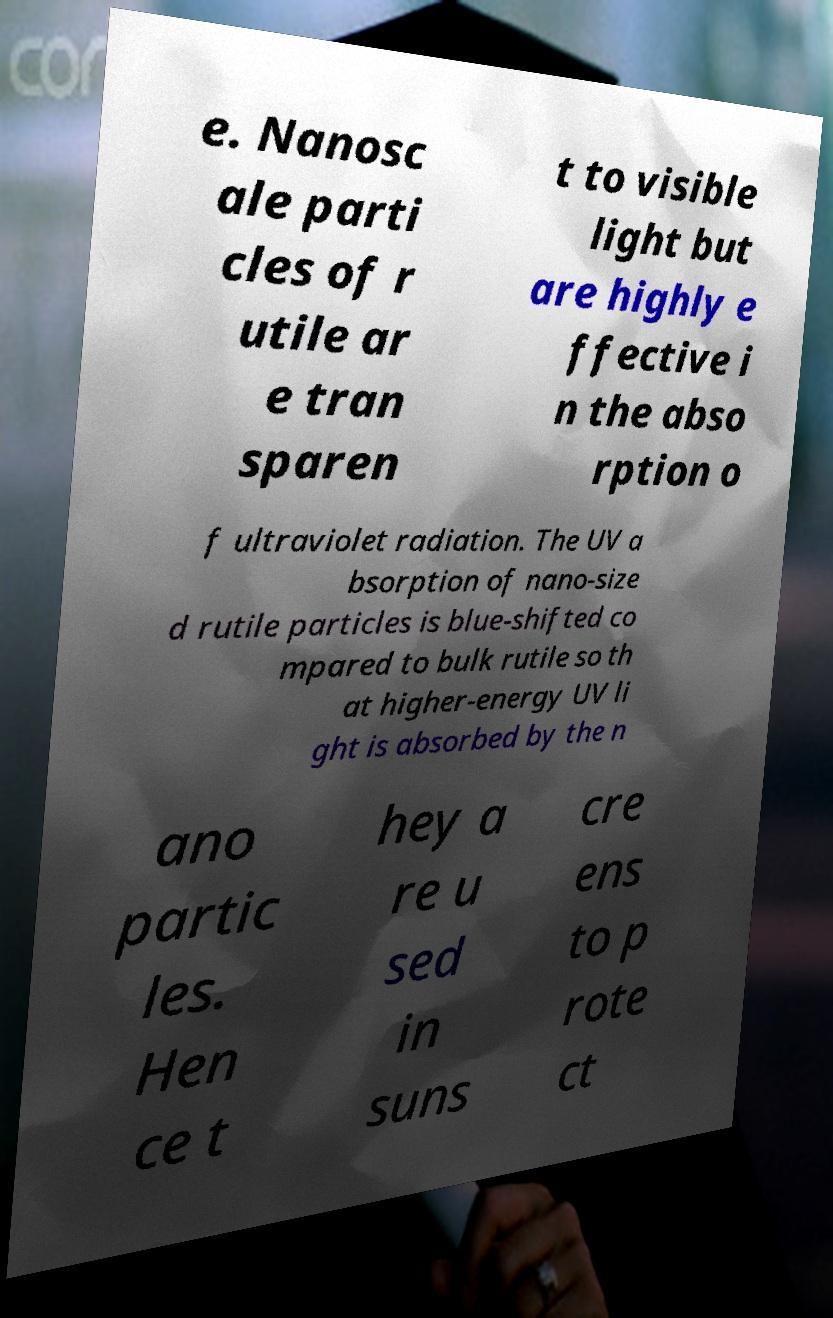For documentation purposes, I need the text within this image transcribed. Could you provide that? e. Nanosc ale parti cles of r utile ar e tran sparen t to visible light but are highly e ffective i n the abso rption o f ultraviolet radiation. The UV a bsorption of nano-size d rutile particles is blue-shifted co mpared to bulk rutile so th at higher-energy UV li ght is absorbed by the n ano partic les. Hen ce t hey a re u sed in suns cre ens to p rote ct 